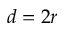<formula> <loc_0><loc_0><loc_500><loc_500>d = 2 r</formula> 